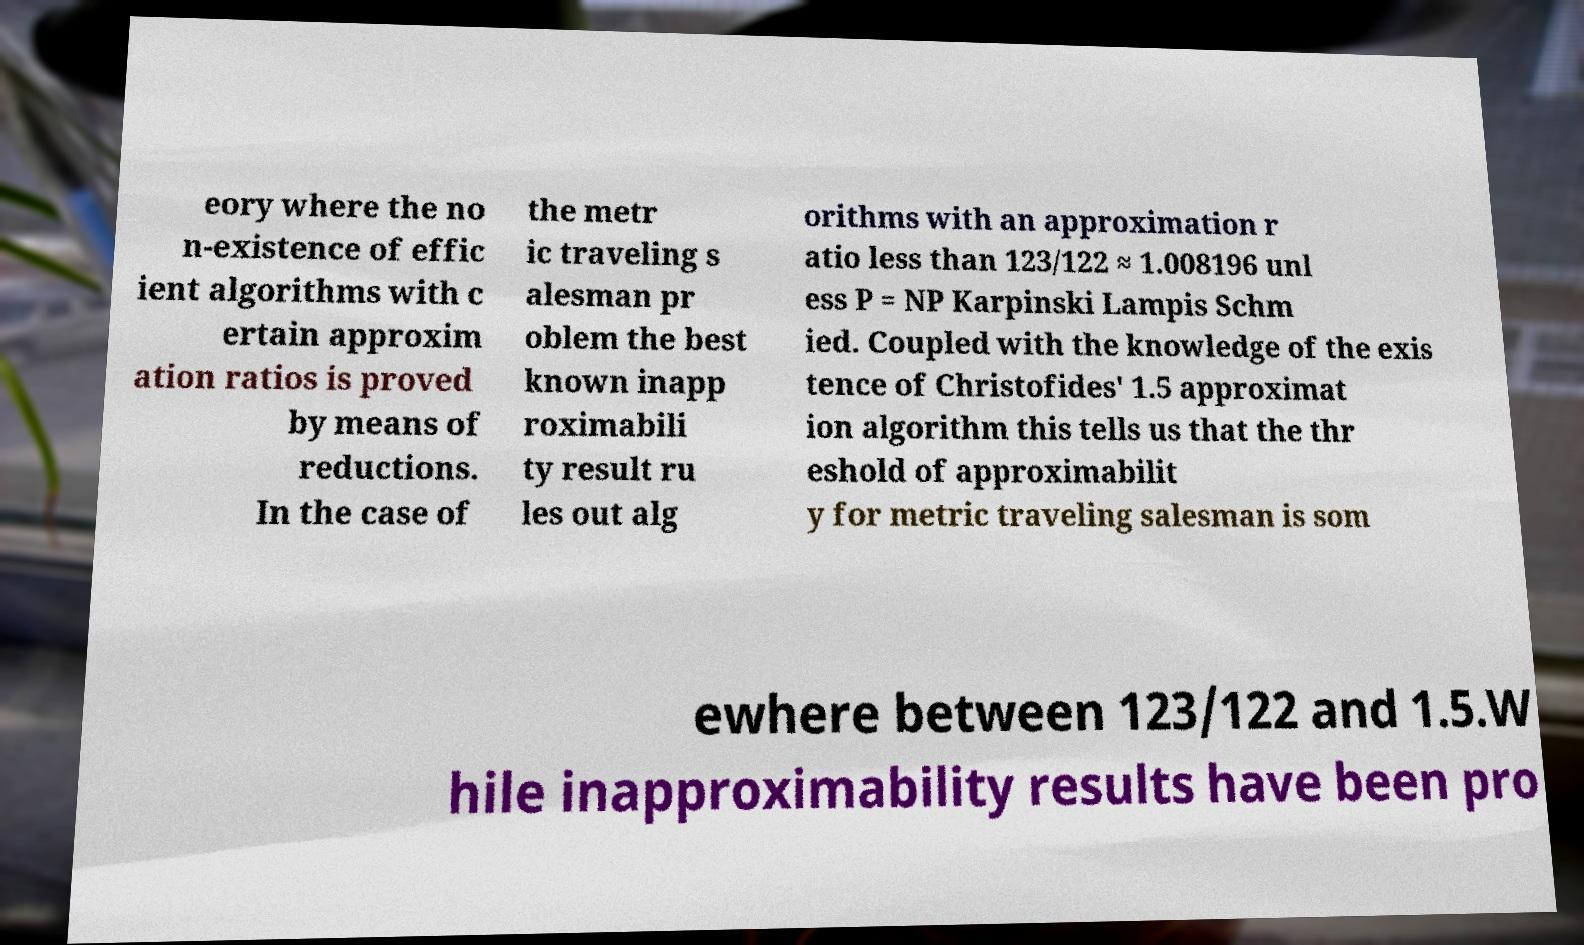What messages or text are displayed in this image? I need them in a readable, typed format. eory where the no n-existence of effic ient algorithms with c ertain approxim ation ratios is proved by means of reductions. In the case of the metr ic traveling s alesman pr oblem the best known inapp roximabili ty result ru les out alg orithms with an approximation r atio less than 123/122 ≈ 1.008196 unl ess P = NP Karpinski Lampis Schm ied. Coupled with the knowledge of the exis tence of Christofides' 1.5 approximat ion algorithm this tells us that the thr eshold of approximabilit y for metric traveling salesman is som ewhere between 123/122 and 1.5.W hile inapproximability results have been pro 